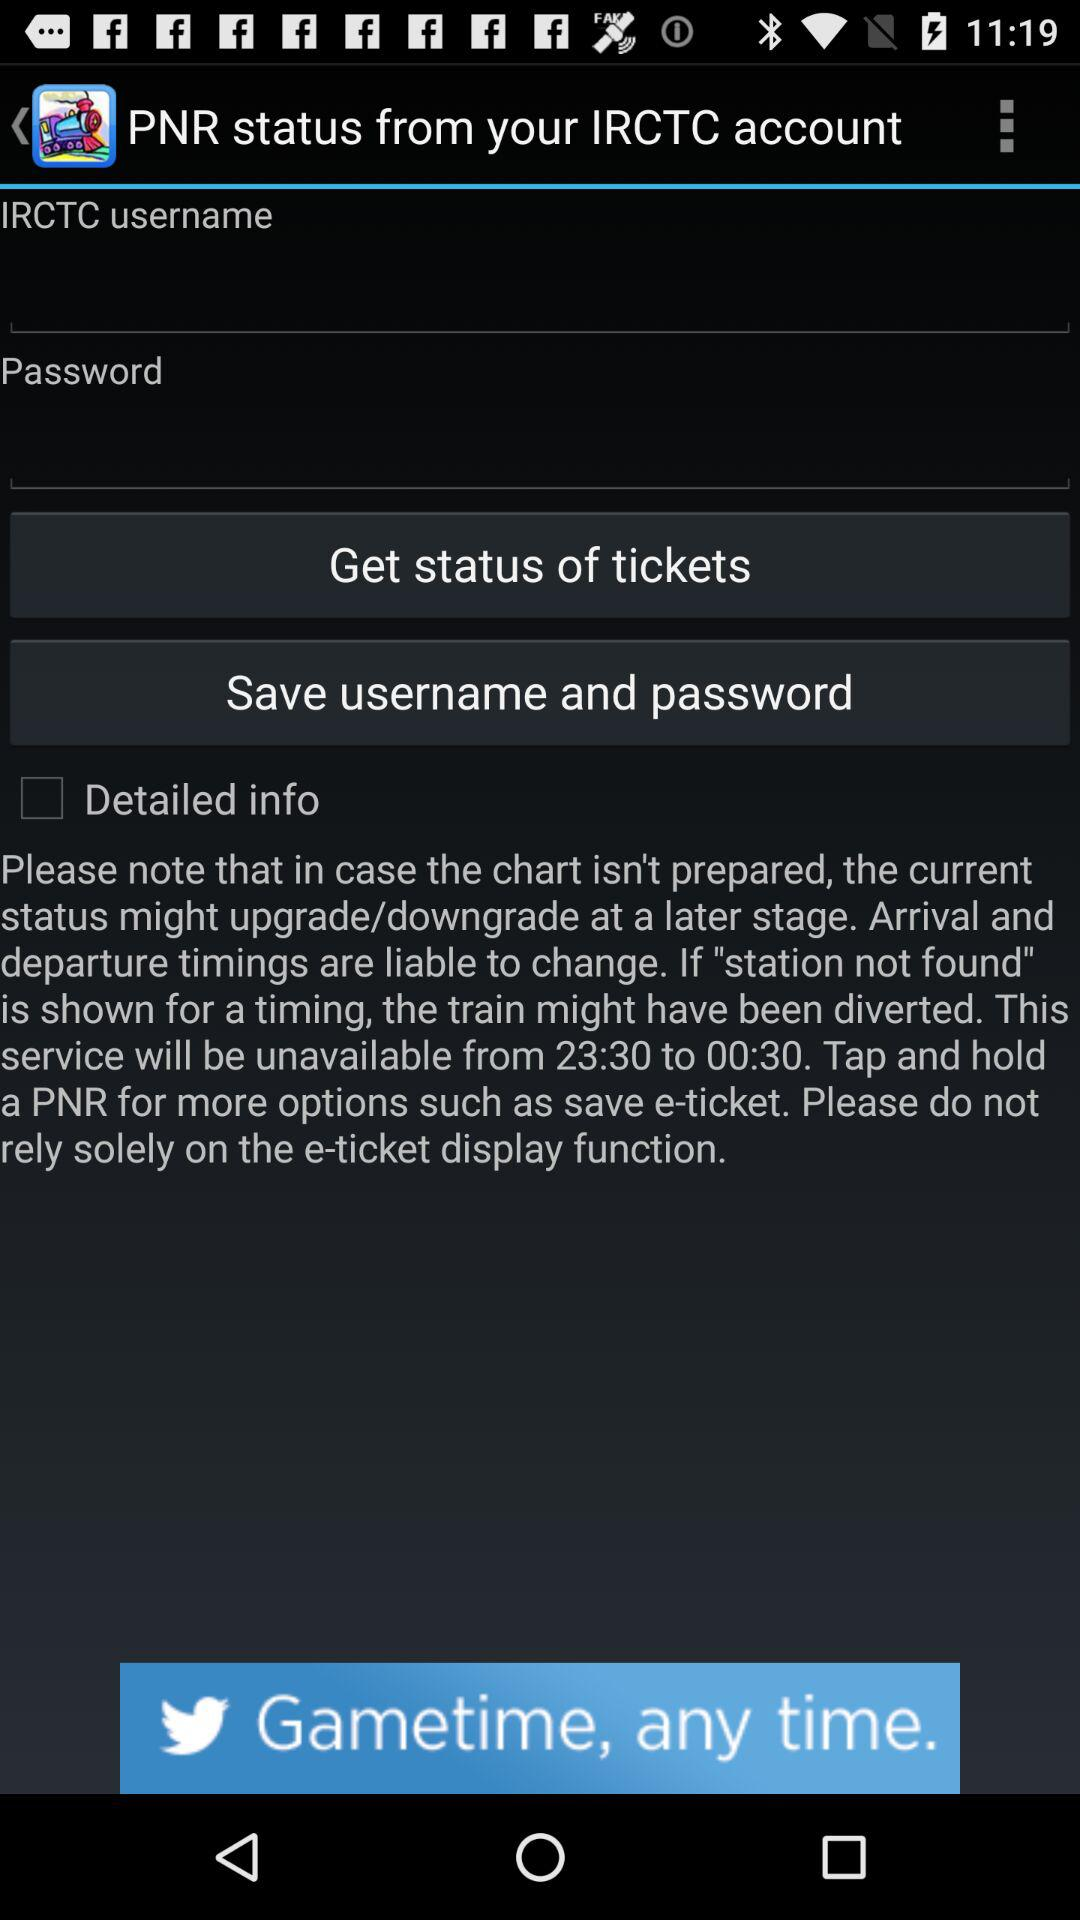What is the status of "Detailed info"? The status is "off". 